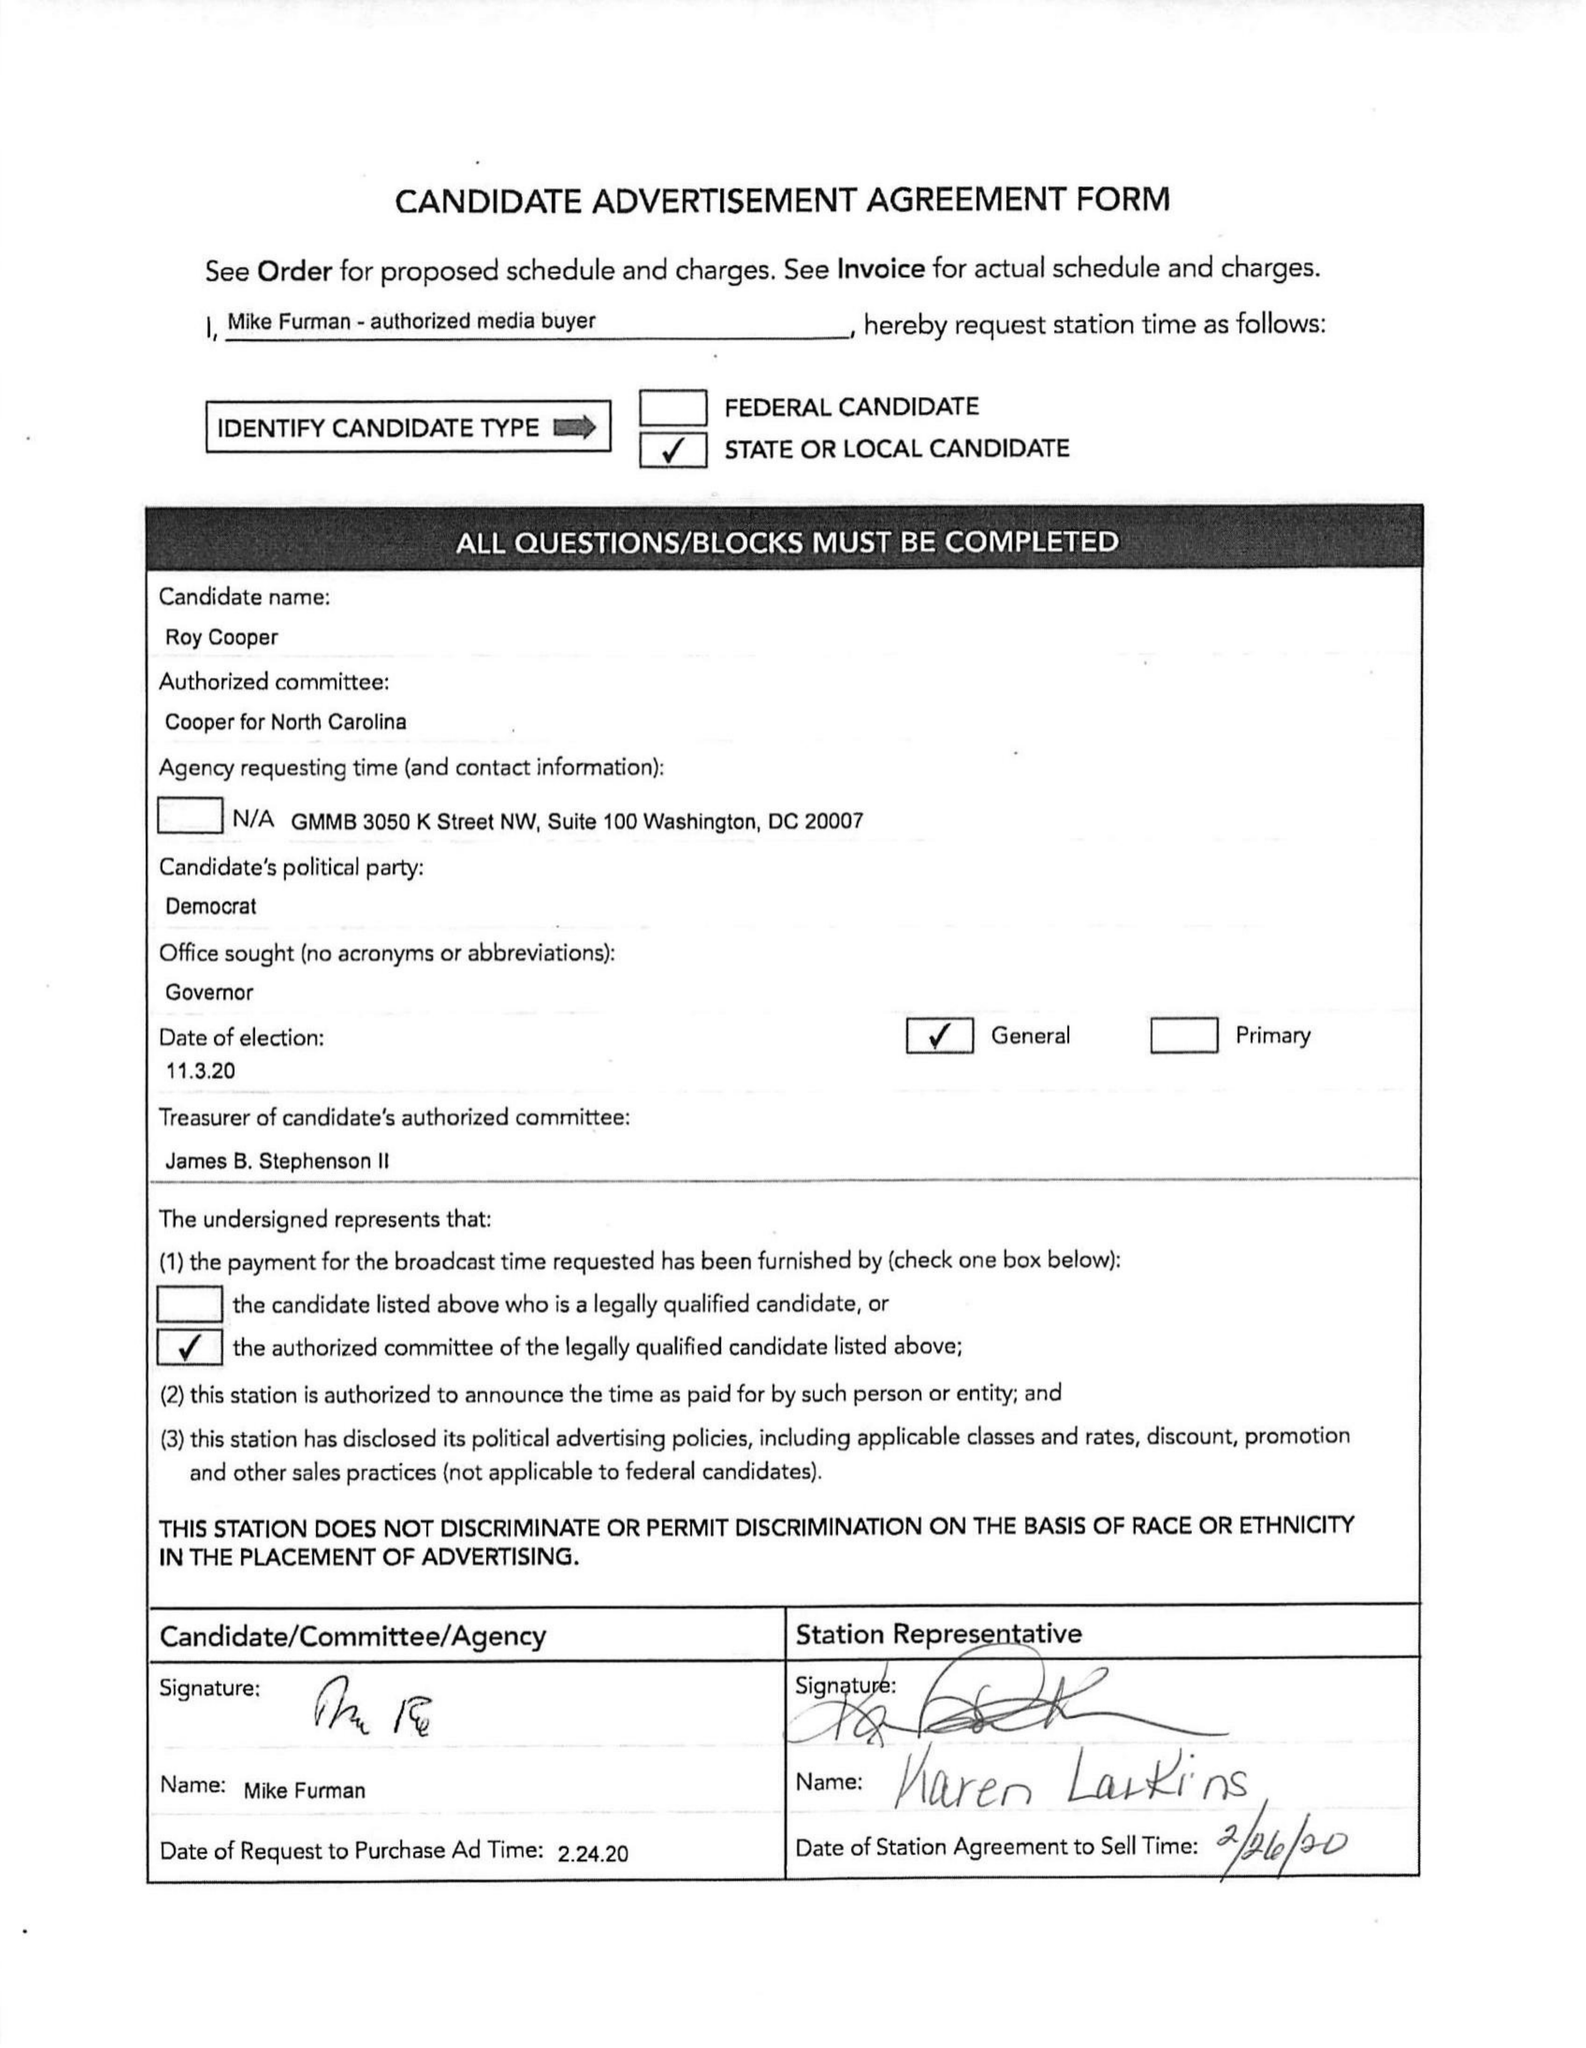What is the value for the gross_amount?
Answer the question using a single word or phrase. 134205.00 